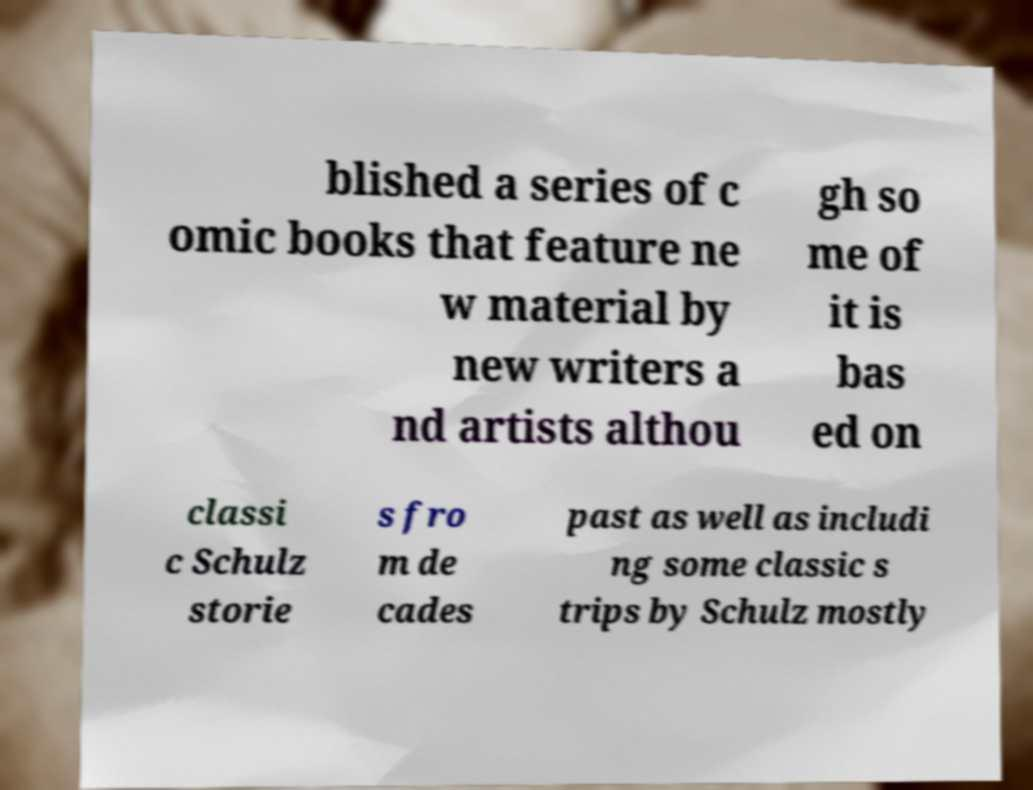For documentation purposes, I need the text within this image transcribed. Could you provide that? blished a series of c omic books that feature ne w material by new writers a nd artists althou gh so me of it is bas ed on classi c Schulz storie s fro m de cades past as well as includi ng some classic s trips by Schulz mostly 